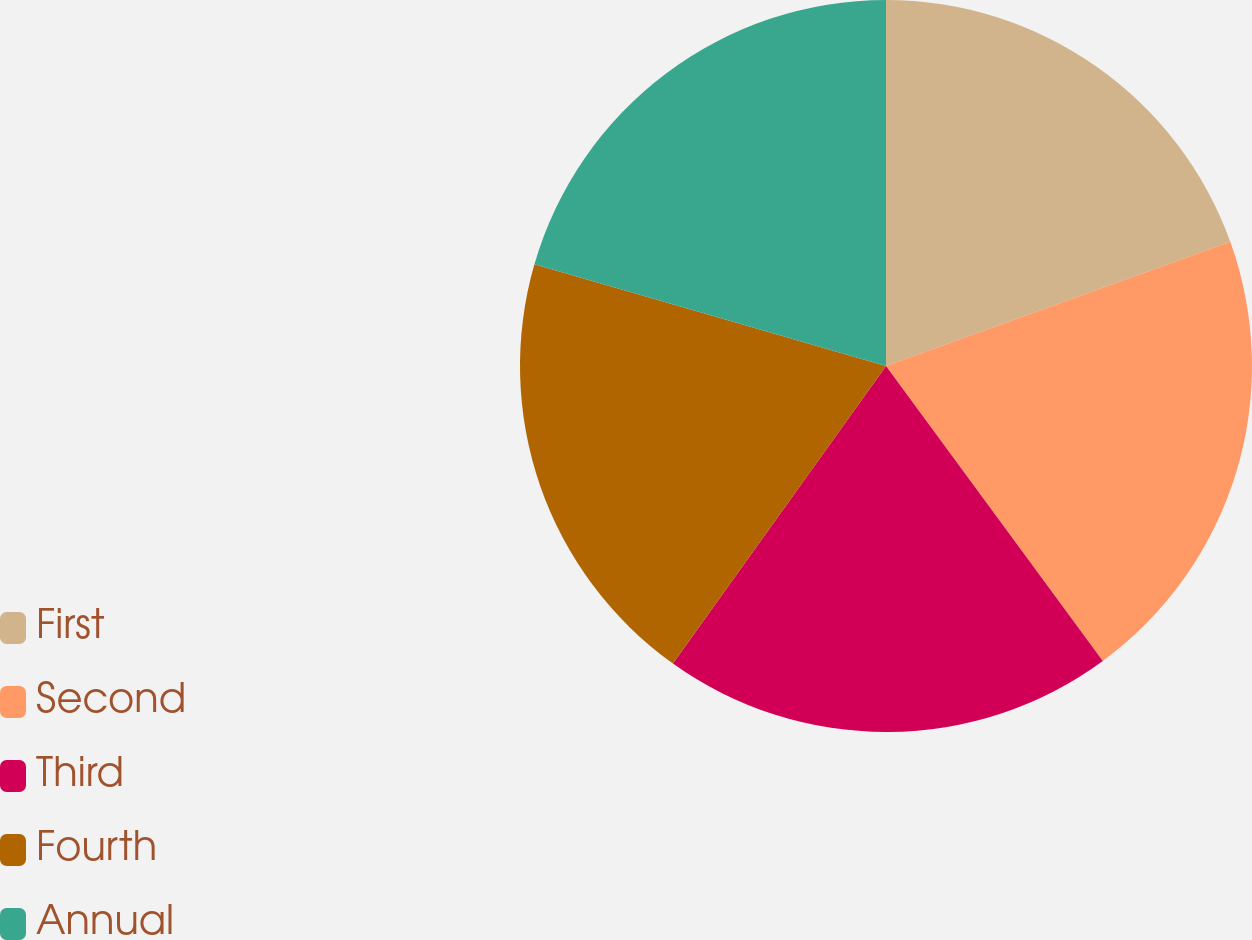Convert chart to OTSL. <chart><loc_0><loc_0><loc_500><loc_500><pie_chart><fcel>First<fcel>Second<fcel>Third<fcel>Fourth<fcel>Annual<nl><fcel>19.49%<fcel>20.42%<fcel>19.98%<fcel>19.59%<fcel>20.52%<nl></chart> 